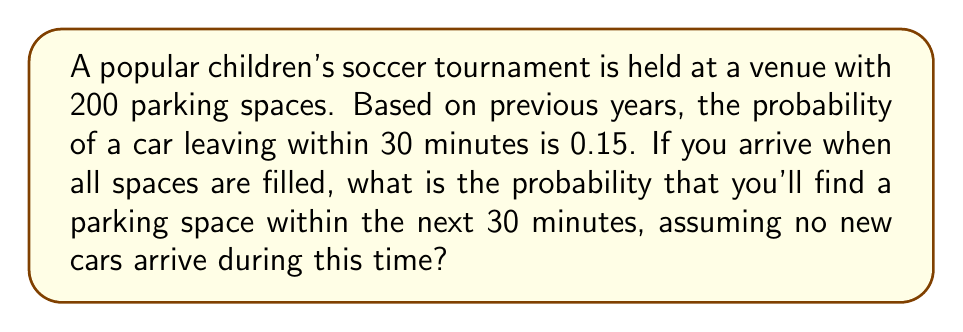Help me with this question. Let's approach this step-by-step:

1) We can model this situation using a binomial distribution. Each parking space has two possible outcomes: a car leaves (success) or it doesn't (failure).

2) We know:
   - Number of trials (parking spaces): $n = 200$
   - Probability of success (a car leaving): $p = 0.15$
   - We need at least one success (one car leaving)

3) The probability of at least one car leaving is the complement of the probability that no cars leave:

   $P(\text{at least one car leaves}) = 1 - P(\text{no cars leave})$

4) The probability that no cars leave follows a binomial distribution:

   $P(\text{no cars leave}) = \binom{200}{0} (0.15)^0 (0.85)^{200}$

5) Simplifying:
   $P(\text{no cars leave}) = 1 \cdot 1 \cdot (0.85)^{200}$

6) Using a calculator (or computer) to evaluate this:
   $P(\text{no cars leave}) \approx 1.456 \times 10^{-14}$

7) Therefore, the probability of finding a parking space is:

   $P(\text{finding a space}) = 1 - P(\text{no cars leave})$
   $= 1 - (1.456 \times 10^{-14})$
   $\approx 0.999999999999985$

8) This is effectively 1, or 100%, when rounded to a reasonable number of decimal places.
Answer: $\approx 1$ or $100\%$ 